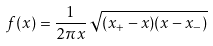<formula> <loc_0><loc_0><loc_500><loc_500>f ( x ) = \frac { 1 } { 2 \pi x } \, \sqrt { ( x _ { + } - x ) ( x - x _ { - } ) }</formula> 